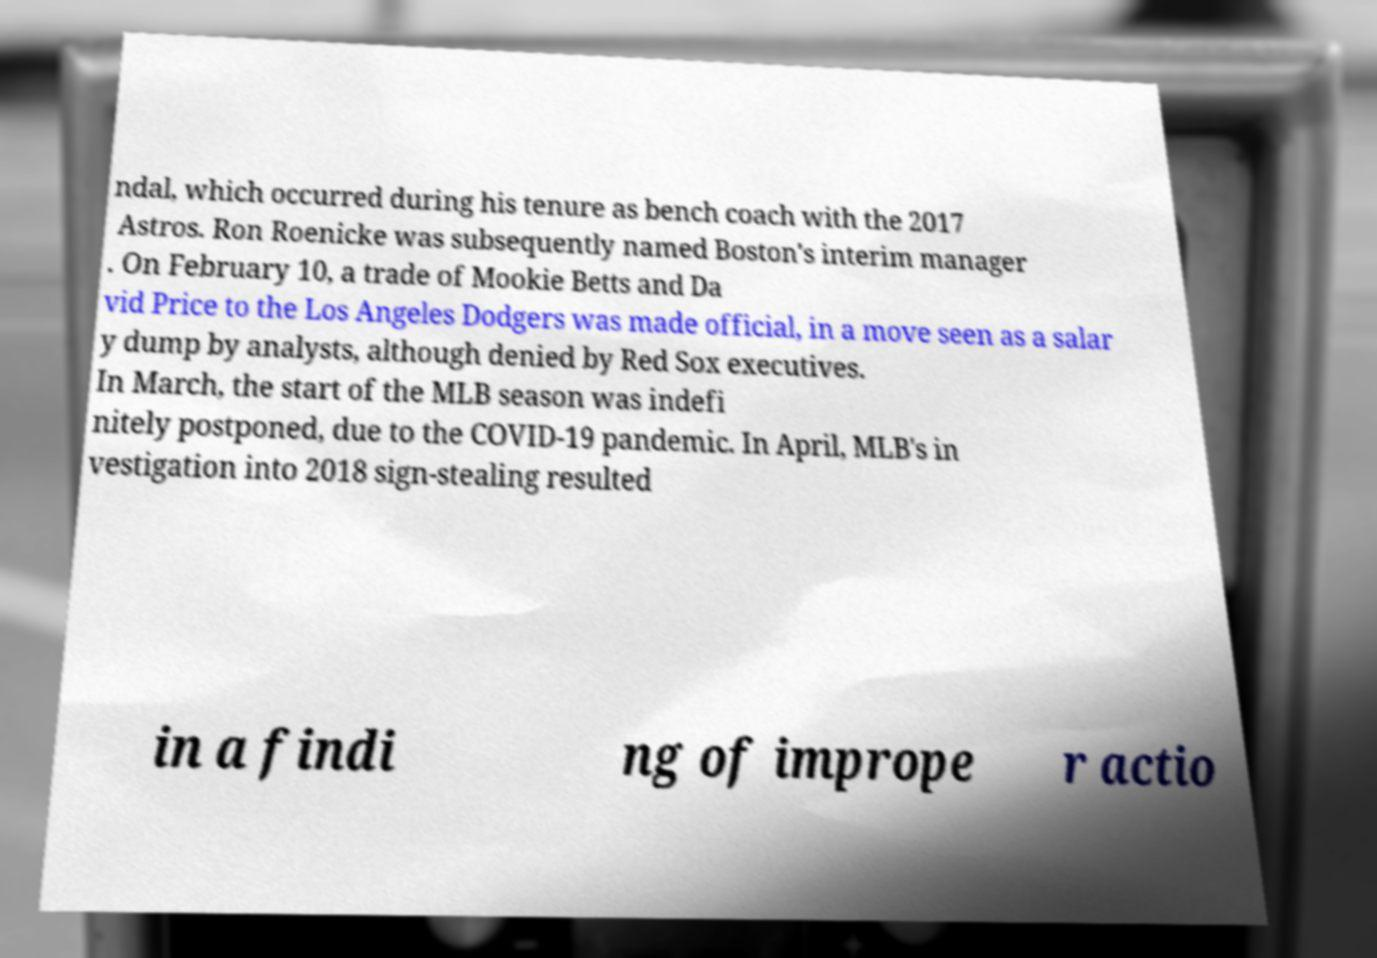I need the written content from this picture converted into text. Can you do that? ndal, which occurred during his tenure as bench coach with the 2017 Astros. Ron Roenicke was subsequently named Boston's interim manager . On February 10, a trade of Mookie Betts and Da vid Price to the Los Angeles Dodgers was made official, in a move seen as a salar y dump by analysts, although denied by Red Sox executives. In March, the start of the MLB season was indefi nitely postponed, due to the COVID-19 pandemic. In April, MLB's in vestigation into 2018 sign-stealing resulted in a findi ng of imprope r actio 